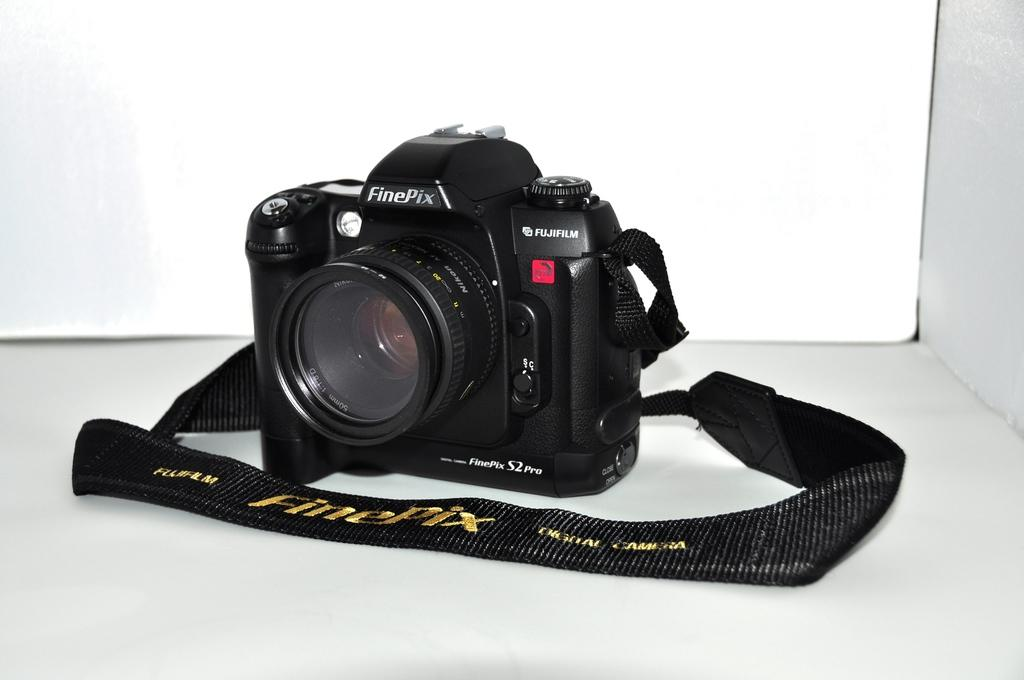What type of camera is in the image? There is a black color camera in the image. What is attached to the camera? The camera has a black color belt. Where is the camera placed? The camera is placed on a white color shelf. What is the color of the background in the image? The background of the image is white in color. What type of prison is visible in the image? There is no prison present in the image; it features a black color camera placed on a white color shelf. What level of respect can be seen in the image? The image does not depict any people or actions that would indicate a level of respect. 